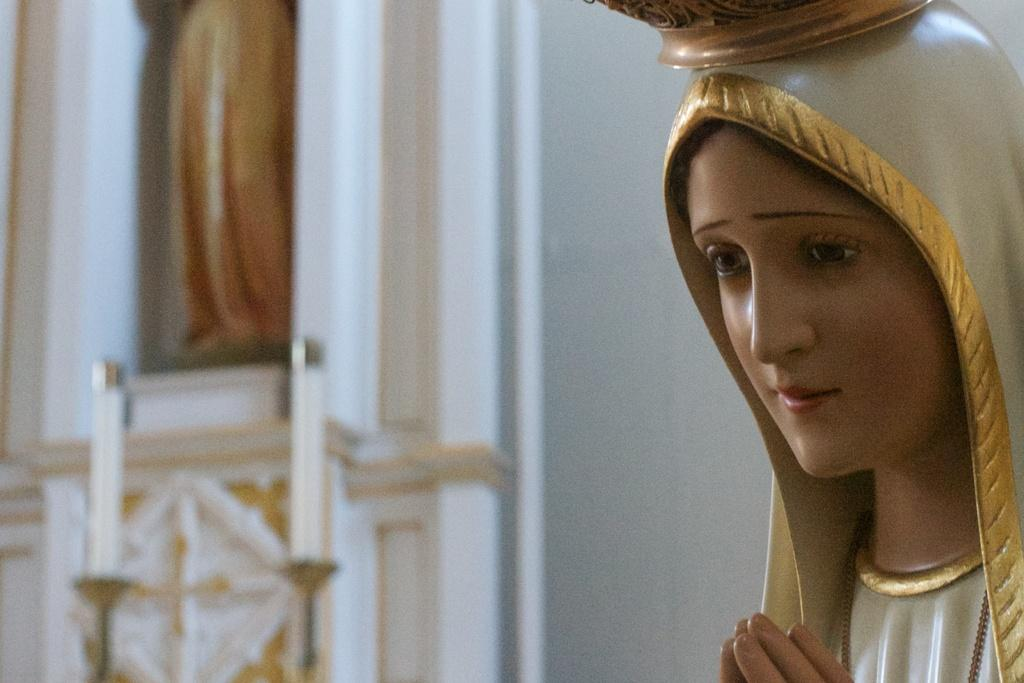What is located on the right side of the image? There is a statue on the right side of the image. Can you describe any other objects or structures in the background area? There may be another statue and a pillar in the background area. What achievement is the boy celebrating in the image? There is no boy present in the image, so it is not possible to determine any achievements being celebrated. 